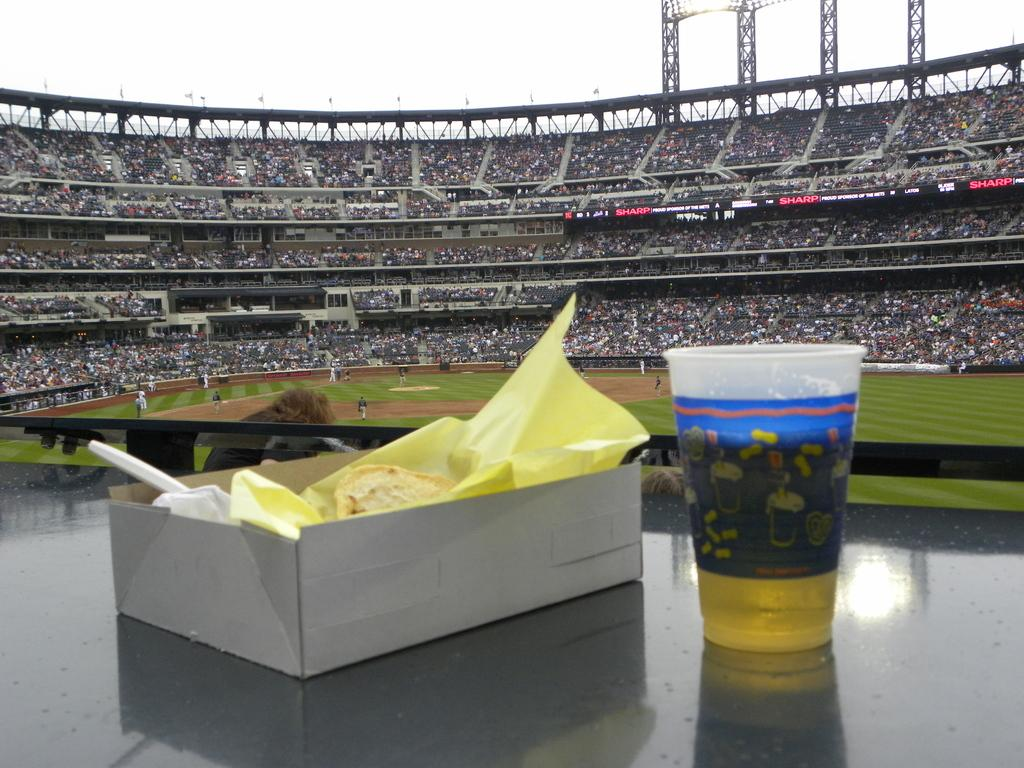What is contained in the box that is visible in the image? There is a box of food items in the image. What else can be seen in the image besides the box of food items? There is a glass of drink in the image. What type of structure is visible in the image? There is a stadium in the image. How many people are present in the image? Many people are present in the image. Where are some of the people located in the image? Some people are present on the ground. What type of chalk is being used by the people in the image? There is no chalk present in the image. What color are the clouds in the image? There are no clouds visible in the image. 